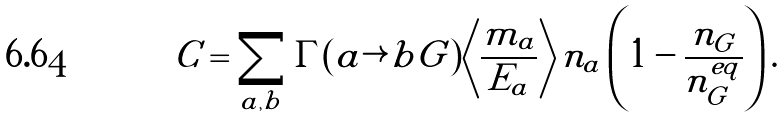Convert formula to latex. <formula><loc_0><loc_0><loc_500><loc_500>C = \sum _ { a , b } \Gamma ( a \rightarrow b \tilde { G } ) \left \langle \frac { m _ { a } } { E _ { a } } \right \rangle n _ { a } \left ( 1 - \frac { n _ { \tilde { G } } } { n _ { \tilde { G } } ^ { e q } } \right ) .</formula> 